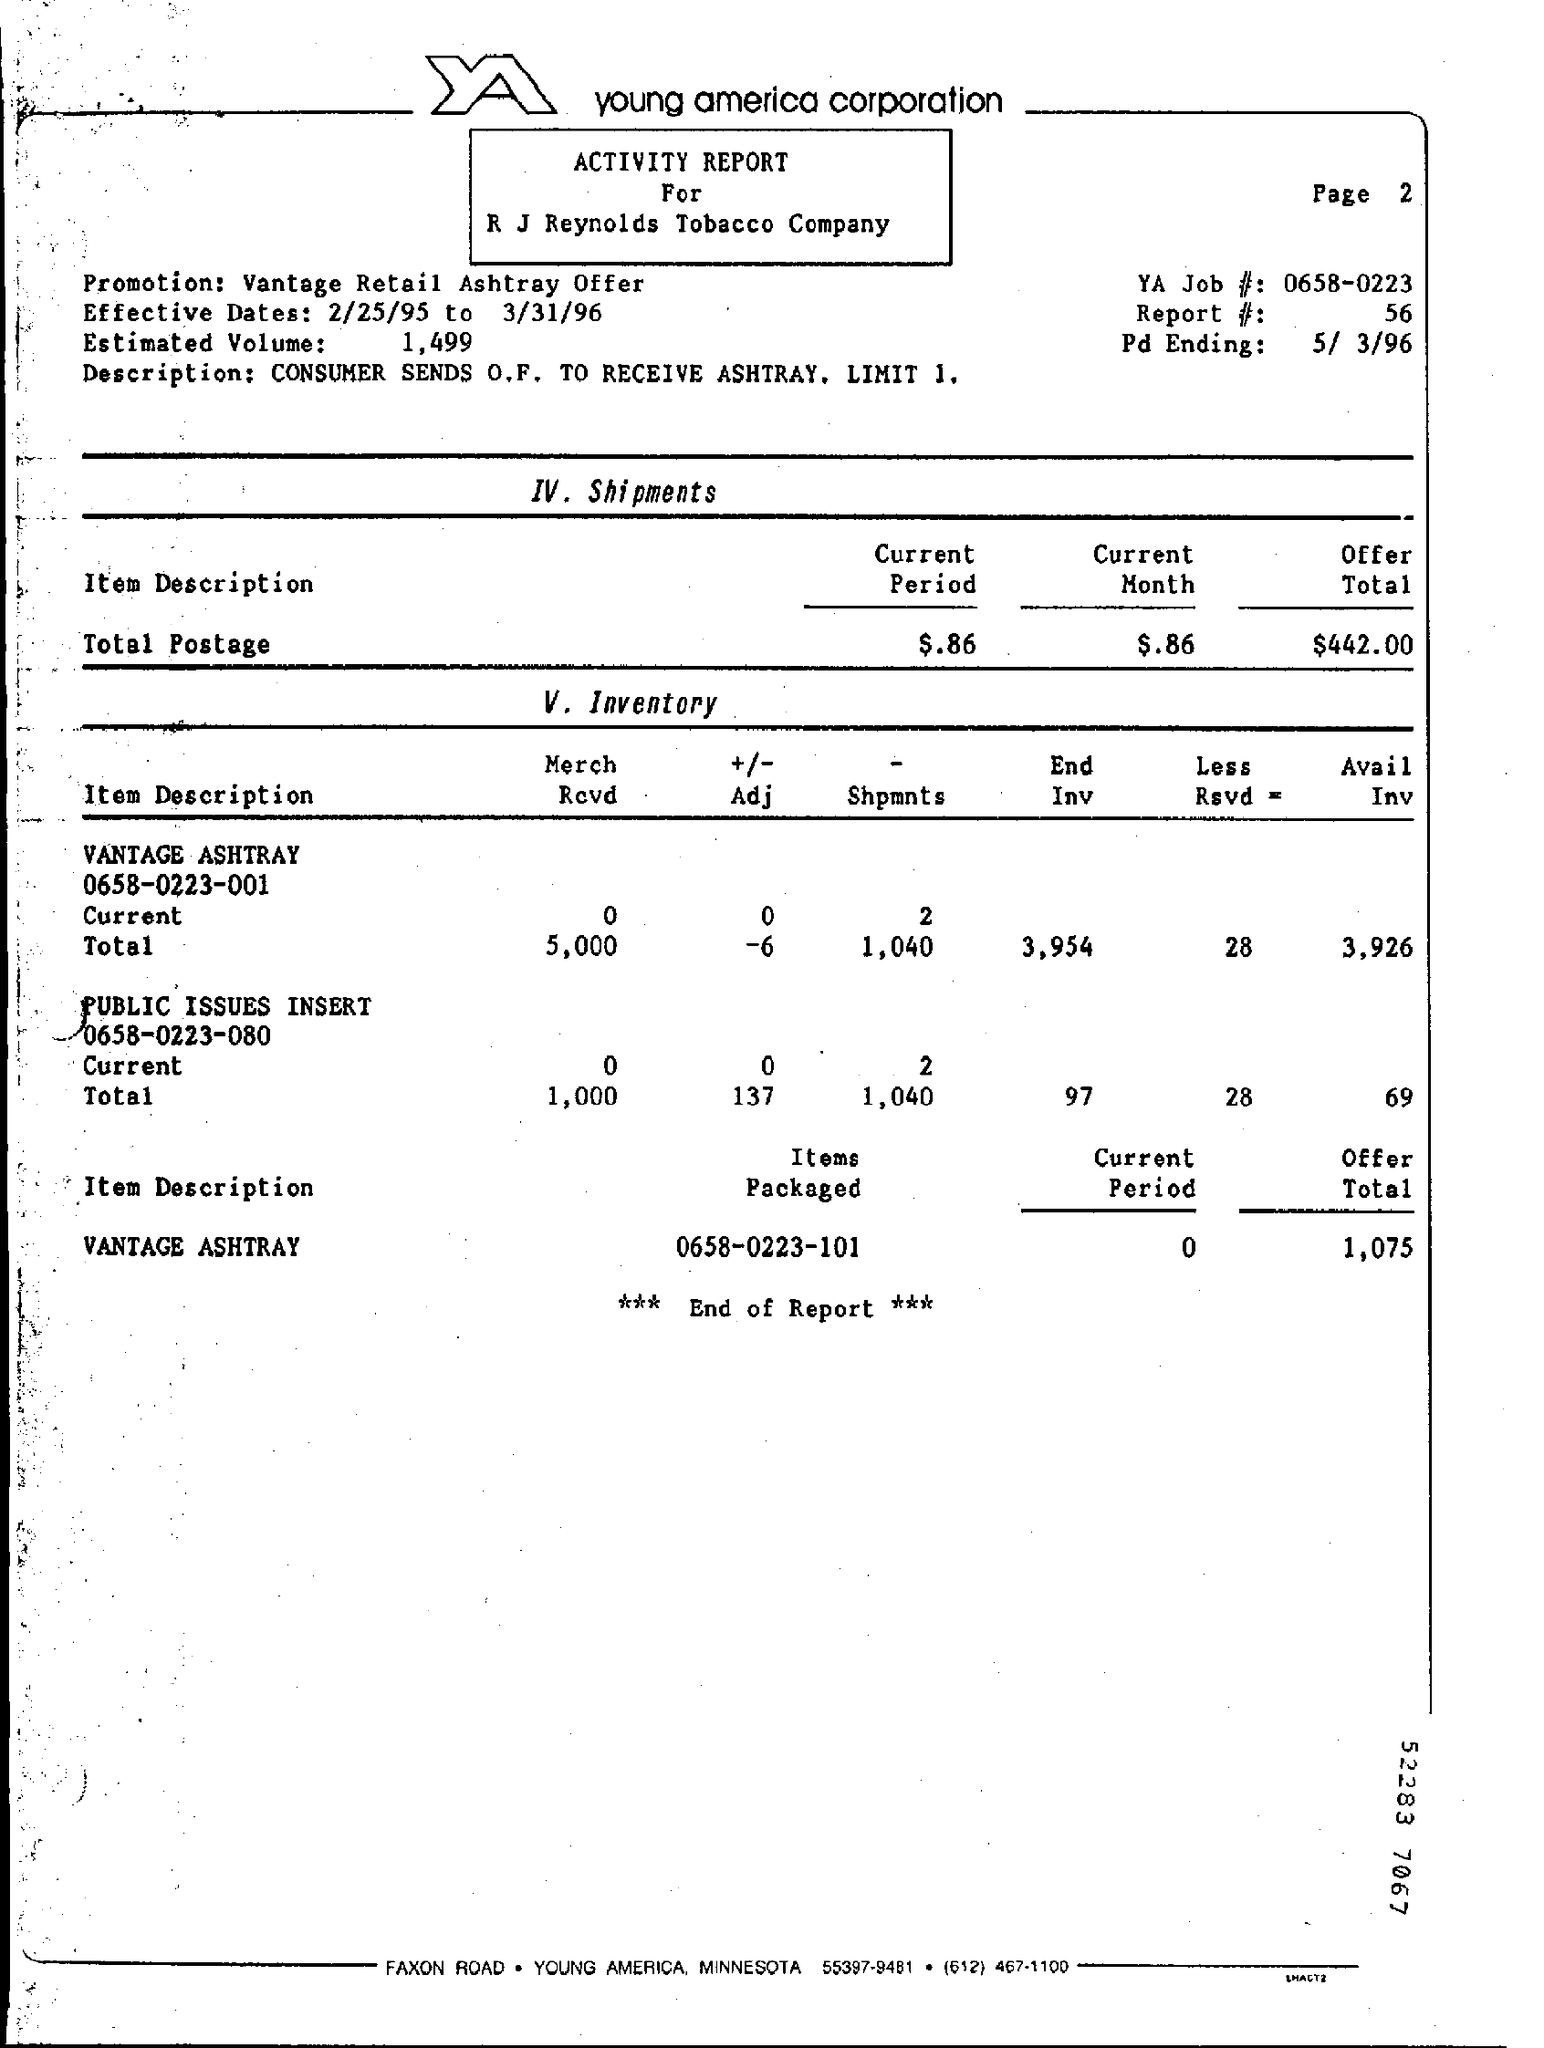Specify some key components in this picture. The report number is 56. The effective dates for the period of 2/25/95 to 3/31/96 are 2/25/95 to 3/31/96. The YA Job number is 0658-0223. 